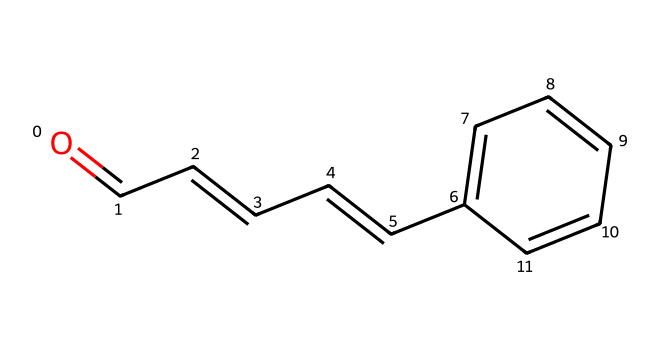What is the common name of this aldehyde? The SMILES representation corresponds to cinnamaldehyde, which is the common name derived from its structure related to cinnamon.
Answer: cinnamaldehyde How many carbon atoms are in this compound? By analyzing the SMILES, we can count the carbon atoms present in the chain and the ring structure. There are a total of 9 carbon atoms.
Answer: 9 What functional group characterizes this aldehyde? Aldehydes are characterized by the presence of a carbonyl group (C=O) at the end of a carbon chain, which is evident in the structure of cinnamaldehyde.
Answer: carbonyl group How many double bonds are found in this molecule? By examining the SMILES, we see that there are 3 double bonds: one in the carbonyl and two in the carbon chain.
Answer: 3 What is the position of the carbonyl group in this aldehyde? The carbonyl group is located at the first carbon in the chain, which is a defining feature of aldehydes, distinguishing them from ketones.
Answer: 1 What type of isomerism does cinnamaldehyde exhibit? Cinnamaldehyde can exhibit cis-trans isomerism due to the presence of a double bond in the carbon chain, leading to different configurations based on the orientation of substituents.
Answer: cis-trans isomerism 